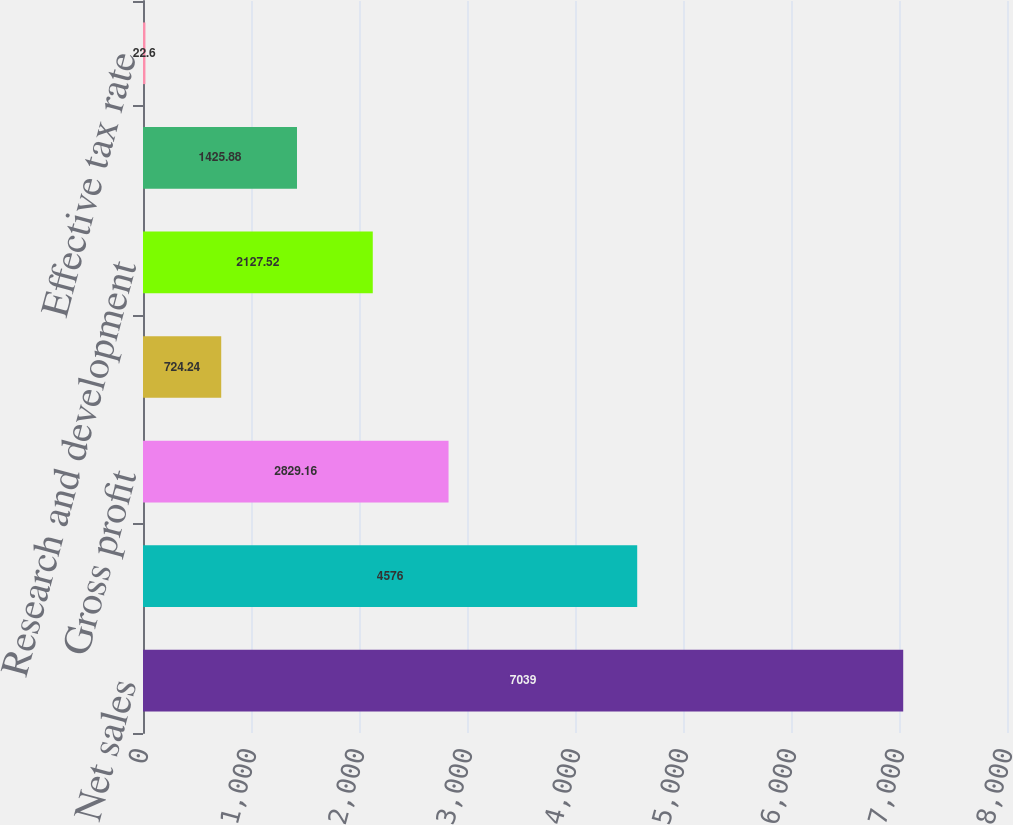<chart> <loc_0><loc_0><loc_500><loc_500><bar_chart><fcel>Net sales<fcel>Cost of goods sold<fcel>Gross profit<fcel>of net sales<fcel>Research and development<fcel>Net interest expense<fcel>Effective tax rate<nl><fcel>7039<fcel>4576<fcel>2829.16<fcel>724.24<fcel>2127.52<fcel>1425.88<fcel>22.6<nl></chart> 